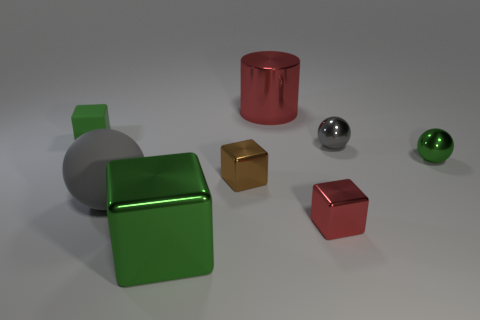What number of other objects are the same material as the cylinder?
Your answer should be compact. 5. What number of things are things that are to the left of the small green metal sphere or tiny brown shiny cubes to the left of the red shiny cylinder?
Provide a succinct answer. 7. What material is the small green thing that is the same shape as the small gray object?
Your answer should be very brief. Metal. Is there a tiny gray matte thing?
Offer a terse response. No. How big is the object that is both to the right of the large green cube and behind the small gray ball?
Give a very brief answer. Large. What is the shape of the large gray thing?
Your response must be concise. Sphere. There is a tiny green thing that is in front of the small green block; is there a tiny green rubber cube that is left of it?
Offer a terse response. Yes. There is a gray thing that is the same size as the green shiny block; what is it made of?
Your response must be concise. Rubber. Are there any red cubes of the same size as the green metal sphere?
Offer a terse response. Yes. What material is the cube behind the tiny brown shiny thing?
Offer a terse response. Rubber. 